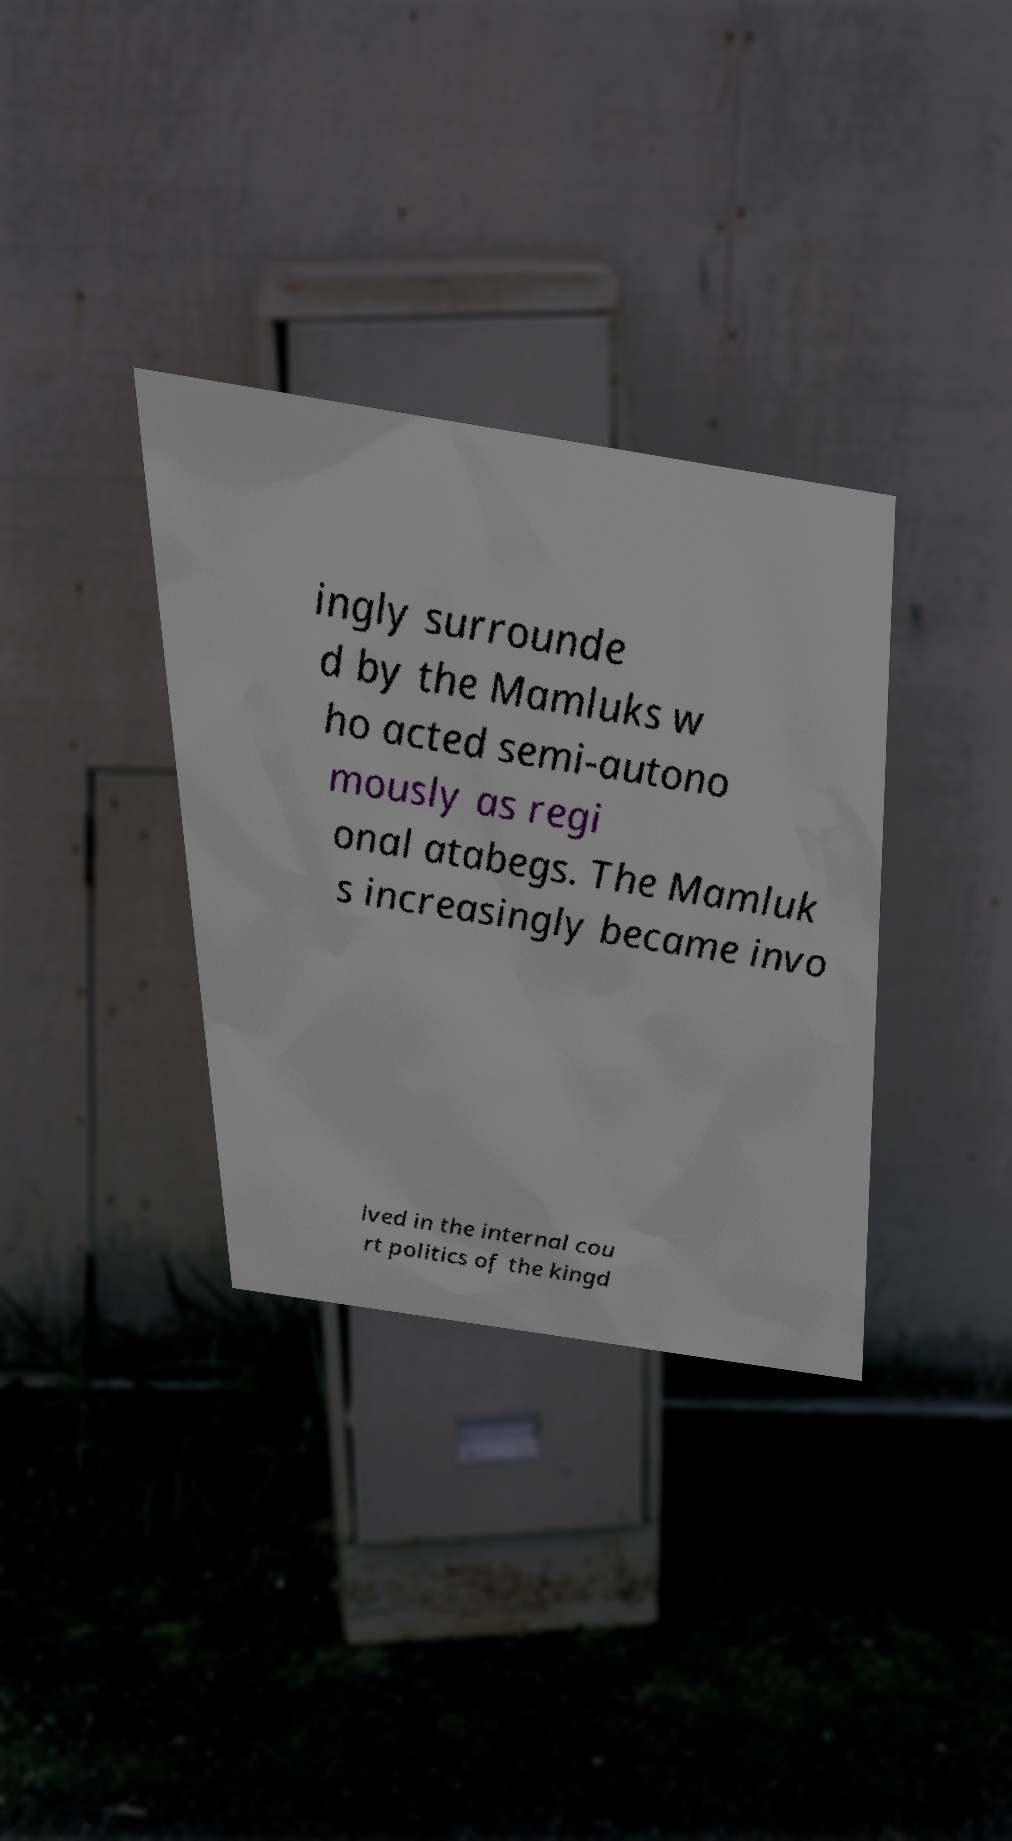Can you accurately transcribe the text from the provided image for me? ingly surrounde d by the Mamluks w ho acted semi-autono mously as regi onal atabegs. The Mamluk s increasingly became invo lved in the internal cou rt politics of the kingd 